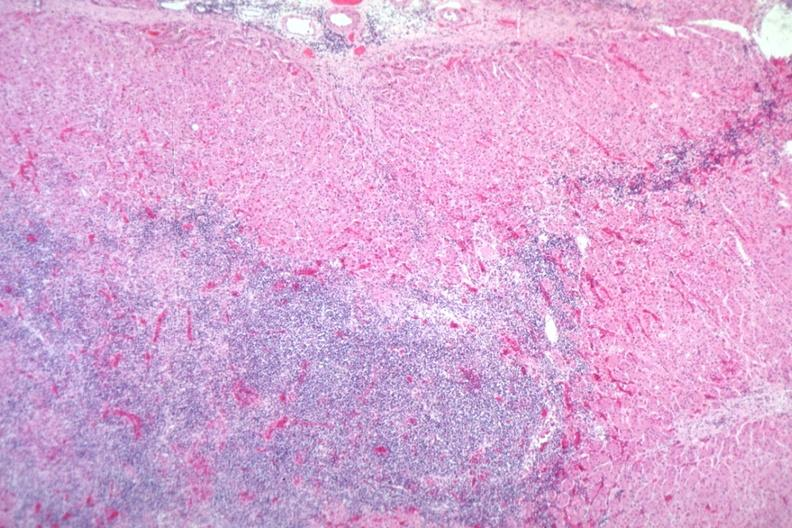what is present?
Answer the question using a single word or phrase. Lymphoma 